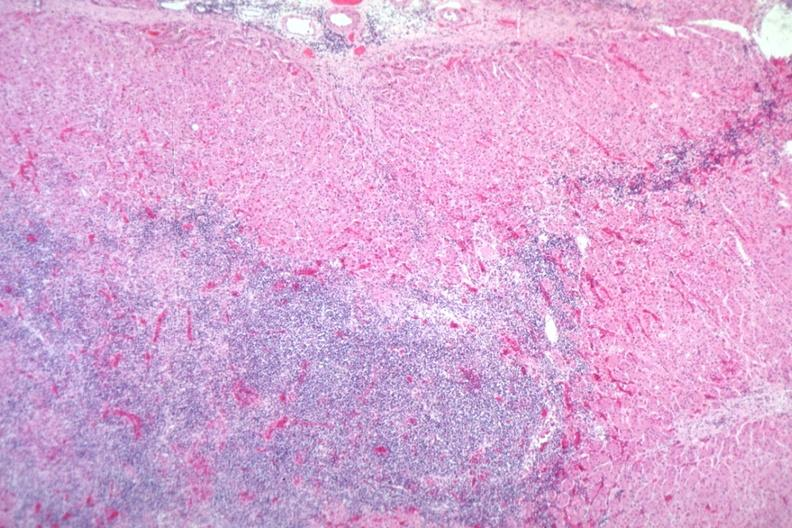what is present?
Answer the question using a single word or phrase. Lymphoma 